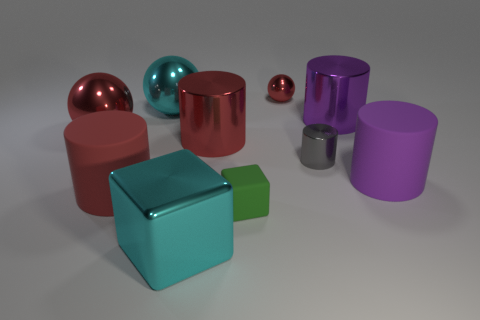Subtract all gray cylinders. How many cylinders are left? 4 Subtract all large red metal cylinders. How many cylinders are left? 4 Subtract 1 cylinders. How many cylinders are left? 4 Subtract all blue cylinders. Subtract all purple cubes. How many cylinders are left? 5 Subtract all cubes. How many objects are left? 8 Add 3 big purple objects. How many big purple objects are left? 5 Add 4 large gray metallic cubes. How many large gray metallic cubes exist? 4 Subtract 0 green cylinders. How many objects are left? 10 Subtract all balls. Subtract all large objects. How many objects are left? 0 